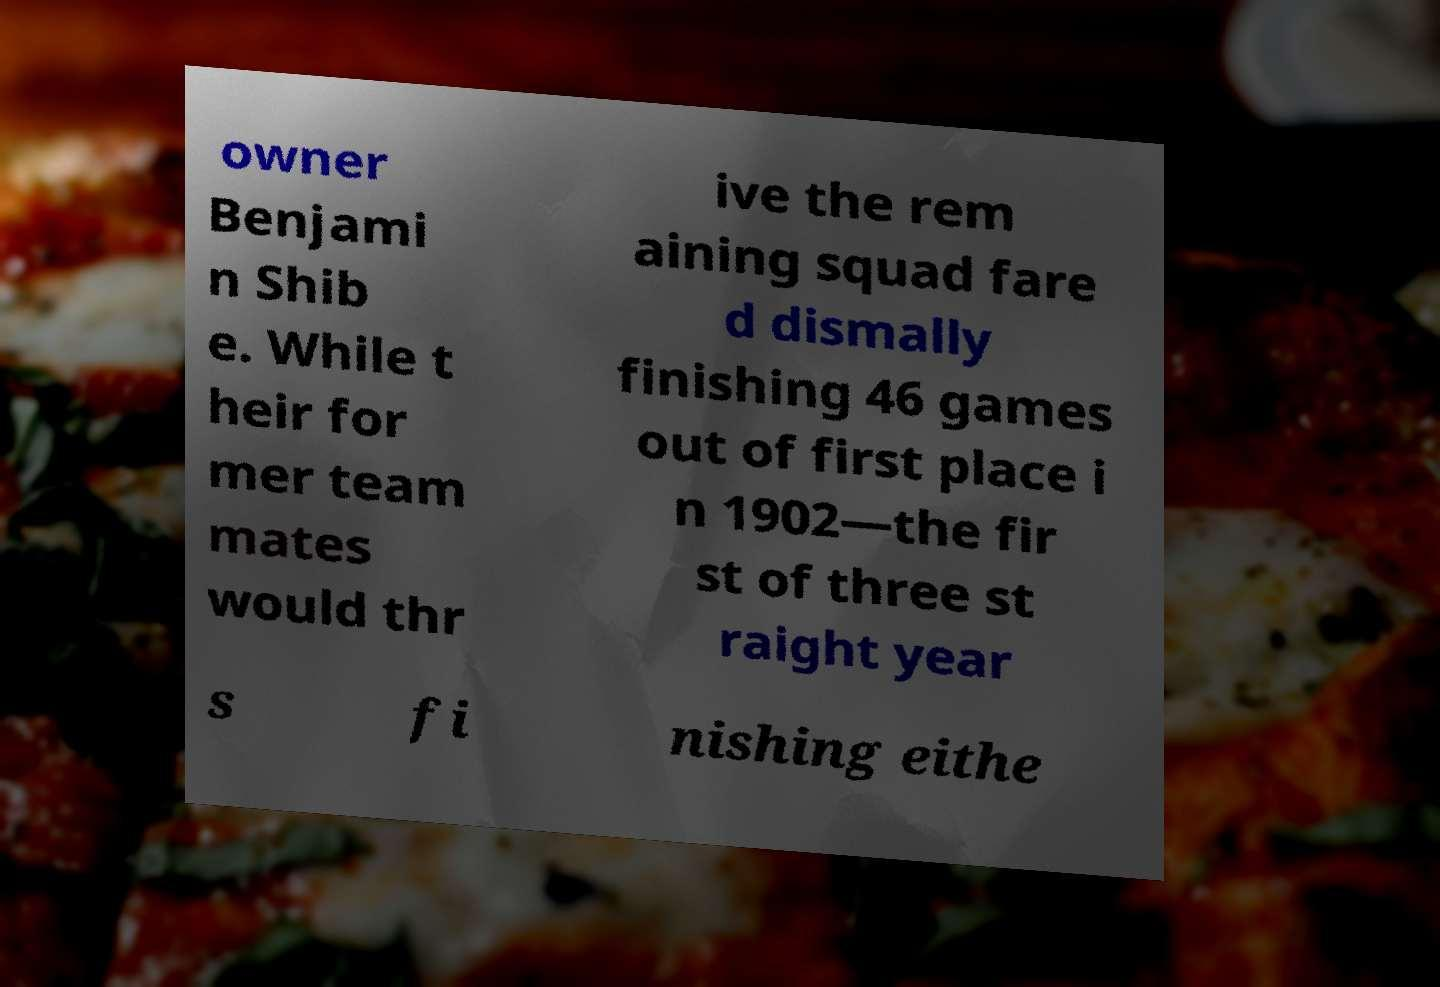Can you read and provide the text displayed in the image?This photo seems to have some interesting text. Can you extract and type it out for me? owner Benjami n Shib e. While t heir for mer team mates would thr ive the rem aining squad fare d dismally finishing 46 games out of first place i n 1902—the fir st of three st raight year s fi nishing eithe 